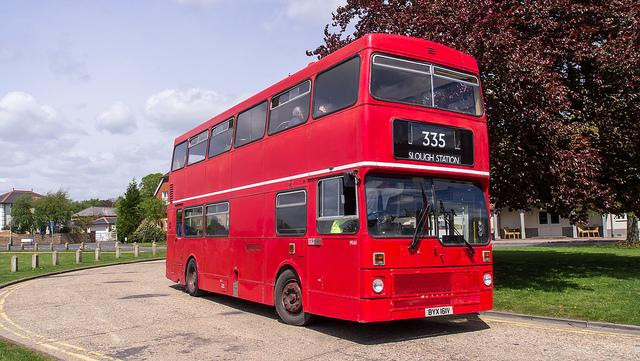One can board a train in which region after they disembark from this bus?

Choices:
A) northern
B) london midland
C) scottish
D) western western 